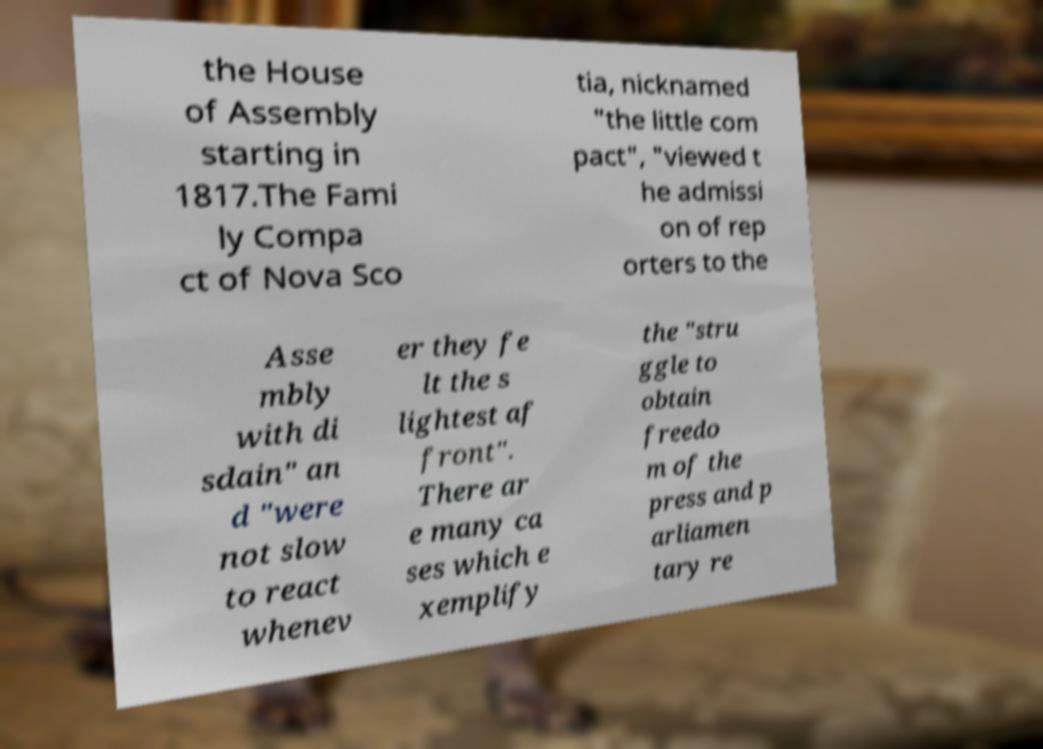Please identify and transcribe the text found in this image. the House of Assembly starting in 1817.The Fami ly Compa ct of Nova Sco tia, nicknamed "the little com pact", "viewed t he admissi on of rep orters to the Asse mbly with di sdain" an d "were not slow to react whenev er they fe lt the s lightest af front". There ar e many ca ses which e xemplify the "stru ggle to obtain freedo m of the press and p arliamen tary re 